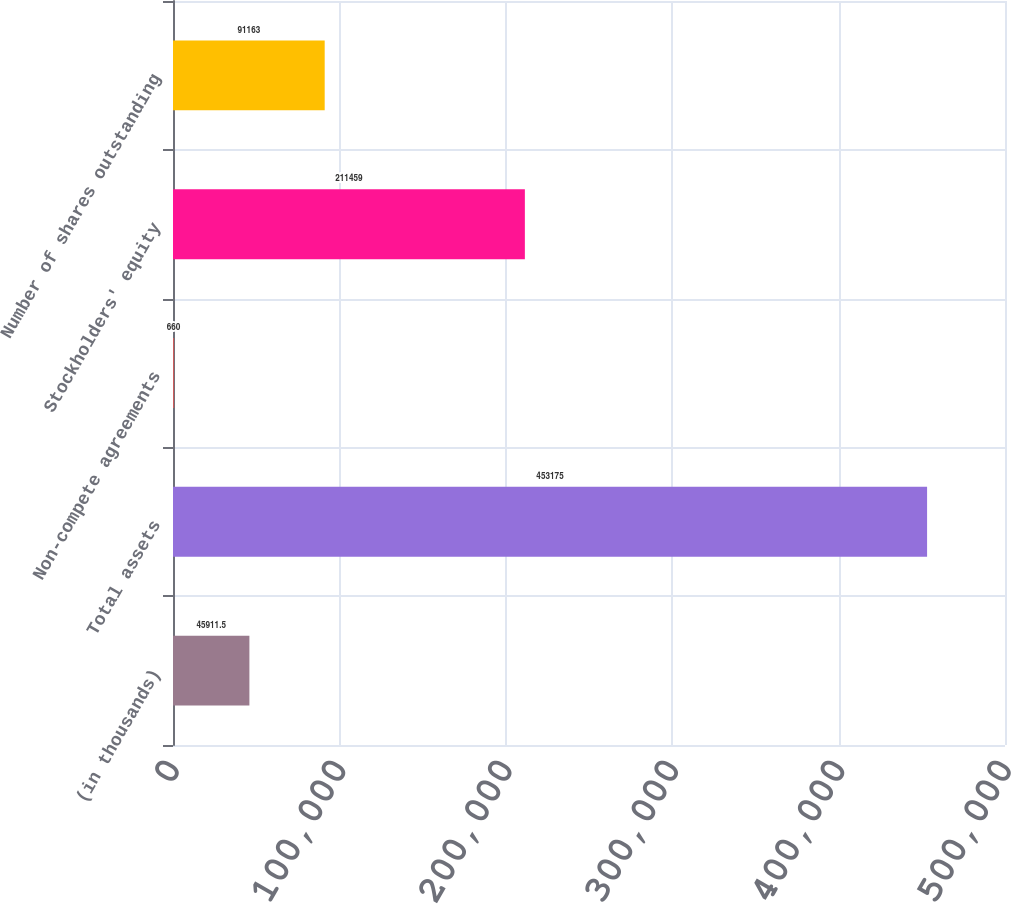Convert chart to OTSL. <chart><loc_0><loc_0><loc_500><loc_500><bar_chart><fcel>(in thousands)<fcel>Total assets<fcel>Non-compete agreements<fcel>Stockholders' equity<fcel>Number of shares outstanding<nl><fcel>45911.5<fcel>453175<fcel>660<fcel>211459<fcel>91163<nl></chart> 